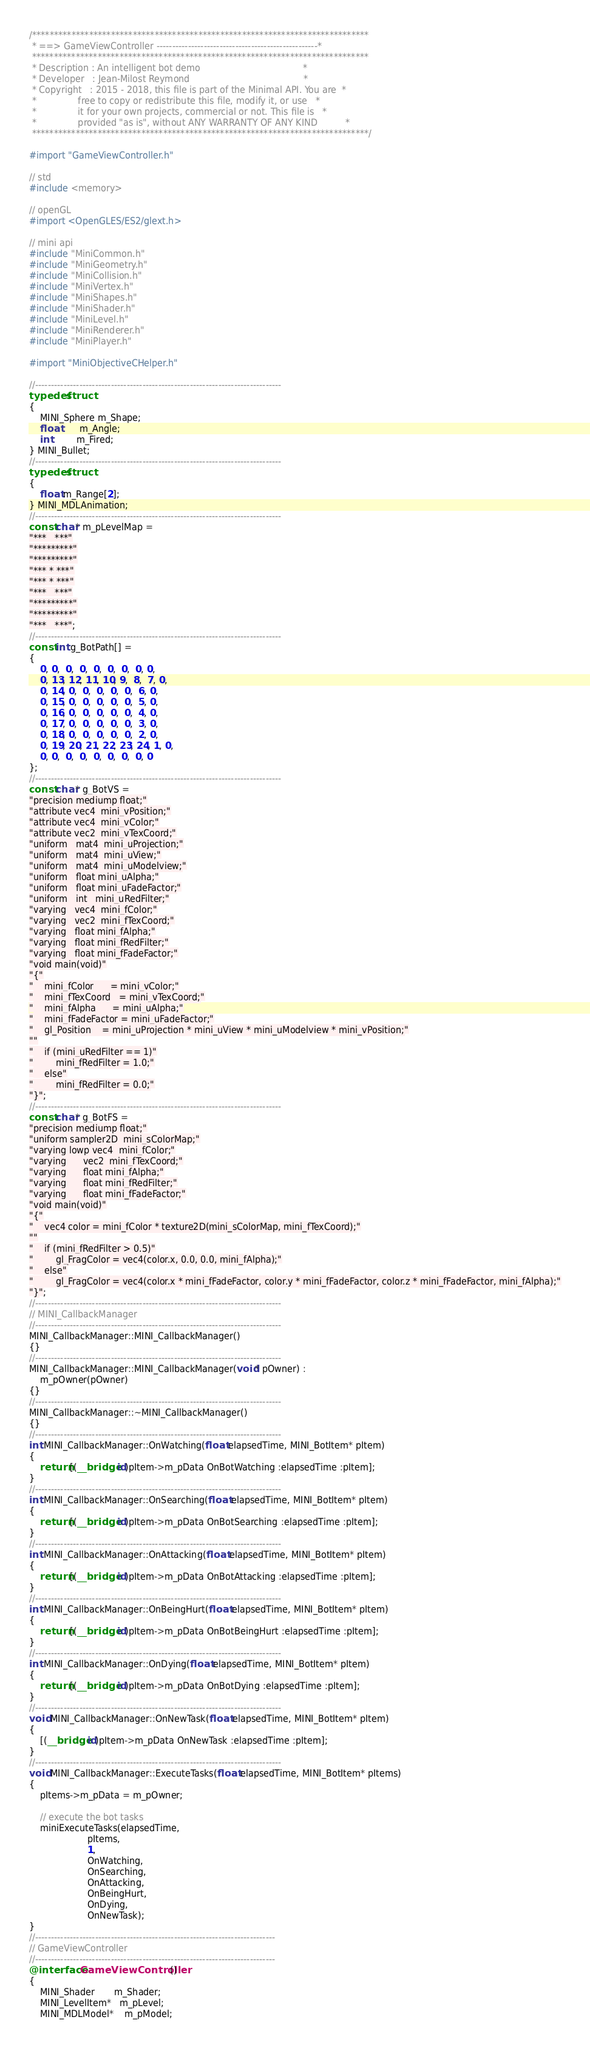Convert code to text. <code><loc_0><loc_0><loc_500><loc_500><_ObjectiveC_>/*****************************************************************************
 * ==> GameViewController ---------------------------------------------------*
 *****************************************************************************
 * Description : An intelligent bot demo                                     *
 * Developer   : Jean-Milost Reymond                                         *
 * Copyright   : 2015 - 2018, this file is part of the Minimal API. You are  *
 *               free to copy or redistribute this file, modify it, or use   *
 *               it for your own projects, commercial or not. This file is   *
 *               provided "as is", without ANY WARRANTY OF ANY KIND          *
 *****************************************************************************/

#import "GameViewController.h"

// std
#include <memory>

// openGL
#import <OpenGLES/ES2/glext.h>

// mini api
#include "MiniCommon.h"
#include "MiniGeometry.h"
#include "MiniCollision.h"
#include "MiniVertex.h"
#include "MiniShapes.h"
#include "MiniShader.h"
#include "MiniLevel.h"
#include "MiniRenderer.h"
#include "MiniPlayer.h"

#import "MiniObjectiveCHelper.h"

//------------------------------------------------------------------------------
typedef struct
{
    MINI_Sphere m_Shape;
    float       m_Angle;
    int         m_Fired;
} MINI_Bullet;
//------------------------------------------------------------------------------
typedef struct
{
    float m_Range[2];
} MINI_MDLAnimation;
//------------------------------------------------------------------------------
const char* m_pLevelMap =
"***   ***"
"*********"
"*********"
"*** * ***"
"*** * ***"
"***   ***"
"*********"
"*********"
"***   ***";
//------------------------------------------------------------------------------
const int g_BotPath[] =
{
    0, 0,  0,  0,  0,  0,  0,  0, 0,
    0, 13, 12, 11, 10, 9,  8,  7, 0,
    0, 14, 0,  0,  0,  0,  0,  6, 0,
    0, 15, 0,  0,  0,  0,  0,  5, 0,
    0, 16, 0,  0,  0,  0,  0,  4, 0,
    0, 17, 0,  0,  0,  0,  0,  3, 0,
    0, 18, 0,  0,  0,  0,  0,  2, 0,
    0, 19, 20, 21, 22, 23, 24, 1, 0,
    0, 0,  0,  0,  0,  0,  0,  0, 0
};
//------------------------------------------------------------------------------
const char* g_BotVS =
"precision mediump float;"
"attribute vec4  mini_vPosition;"
"attribute vec4  mini_vColor;"
"attribute vec2  mini_vTexCoord;"
"uniform   mat4  mini_uProjection;"
"uniform   mat4  mini_uView;"
"uniform   mat4  mini_uModelview;"
"uniform   float mini_uAlpha;"
"uniform   float mini_uFadeFactor;"
"uniform   int   mini_uRedFilter;"
"varying   vec4  mini_fColor;"
"varying   vec2  mini_fTexCoord;"
"varying   float mini_fAlpha;"
"varying   float mini_fRedFilter;"
"varying   float mini_fFadeFactor;"
"void main(void)"
"{"
"    mini_fColor      = mini_vColor;"
"    mini_fTexCoord   = mini_vTexCoord;"
"    mini_fAlpha      = mini_uAlpha;"
"    mini_fFadeFactor = mini_uFadeFactor;"
"    gl_Position    = mini_uProjection * mini_uView * mini_uModelview * mini_vPosition;"
""
"    if (mini_uRedFilter == 1)"
"        mini_fRedFilter = 1.0;"
"    else"
"        mini_fRedFilter = 0.0;"
"}";
//------------------------------------------------------------------------------
const char* g_BotFS =
"precision mediump float;"
"uniform sampler2D  mini_sColorMap;"
"varying lowp vec4  mini_fColor;"
"varying      vec2  mini_fTexCoord;"
"varying      float mini_fAlpha;"
"varying      float mini_fRedFilter;"
"varying      float mini_fFadeFactor;"
"void main(void)"
"{"
"    vec4 color = mini_fColor * texture2D(mini_sColorMap, mini_fTexCoord);"
""
"    if (mini_fRedFilter > 0.5)"
"        gl_FragColor = vec4(color.x, 0.0, 0.0, mini_fAlpha);"
"    else"
"        gl_FragColor = vec4(color.x * mini_fFadeFactor, color.y * mini_fFadeFactor, color.z * mini_fFadeFactor, mini_fAlpha);"
"}";
//------------------------------------------------------------------------------
// MINI_CallbackManager
//------------------------------------------------------------------------------
MINI_CallbackManager::MINI_CallbackManager()
{}
//------------------------------------------------------------------------------
MINI_CallbackManager::MINI_CallbackManager(void* pOwner) :
    m_pOwner(pOwner)
{}
//------------------------------------------------------------------------------
MINI_CallbackManager::~MINI_CallbackManager()
{}
//------------------------------------------------------------------------------
int MINI_CallbackManager::OnWatching(float elapsedTime, MINI_BotItem* pItem)
{
    return [(__bridge id)pItem->m_pData OnBotWatching :elapsedTime :pItem];
}
//------------------------------------------------------------------------------
int MINI_CallbackManager::OnSearching(float elapsedTime, MINI_BotItem* pItem)
{
    return [(__bridge id)pItem->m_pData OnBotSearching :elapsedTime :pItem];
}
//------------------------------------------------------------------------------
int MINI_CallbackManager::OnAttacking(float elapsedTime, MINI_BotItem* pItem)
{
    return [(__bridge id)pItem->m_pData OnBotAttacking :elapsedTime :pItem];
}
//------------------------------------------------------------------------------
int MINI_CallbackManager::OnBeingHurt(float elapsedTime, MINI_BotItem* pItem)
{
    return [(__bridge id)pItem->m_pData OnBotBeingHurt :elapsedTime :pItem];
}
//------------------------------------------------------------------------------
int MINI_CallbackManager::OnDying(float elapsedTime, MINI_BotItem* pItem)
{
    return [(__bridge id)pItem->m_pData OnBotDying :elapsedTime :pItem];
}
//------------------------------------------------------------------------------
void MINI_CallbackManager::OnNewTask(float elapsedTime, MINI_BotItem* pItem)
{
    [(__bridge id)pItem->m_pData OnNewTask :elapsedTime :pItem];
}
//------------------------------------------------------------------------------
void MINI_CallbackManager::ExecuteTasks(float elapsedTime, MINI_BotItem* pItems)
{
    pItems->m_pData = m_pOwner;
    
    // execute the bot tasks
    miniExecuteTasks(elapsedTime,
                     pItems,
                     1,
                     OnWatching,
                     OnSearching,
                     OnAttacking,
                     OnBeingHurt,
                     OnDying,
                     OnNewTask);
}
//----------------------------------------------------------------------------
// GameViewController
//----------------------------------------------------------------------------
@interface GameViewController()
{
    MINI_Shader       m_Shader;
    MINI_LevelItem*   m_pLevel;
    MINI_MDLModel*    m_pModel;</code> 